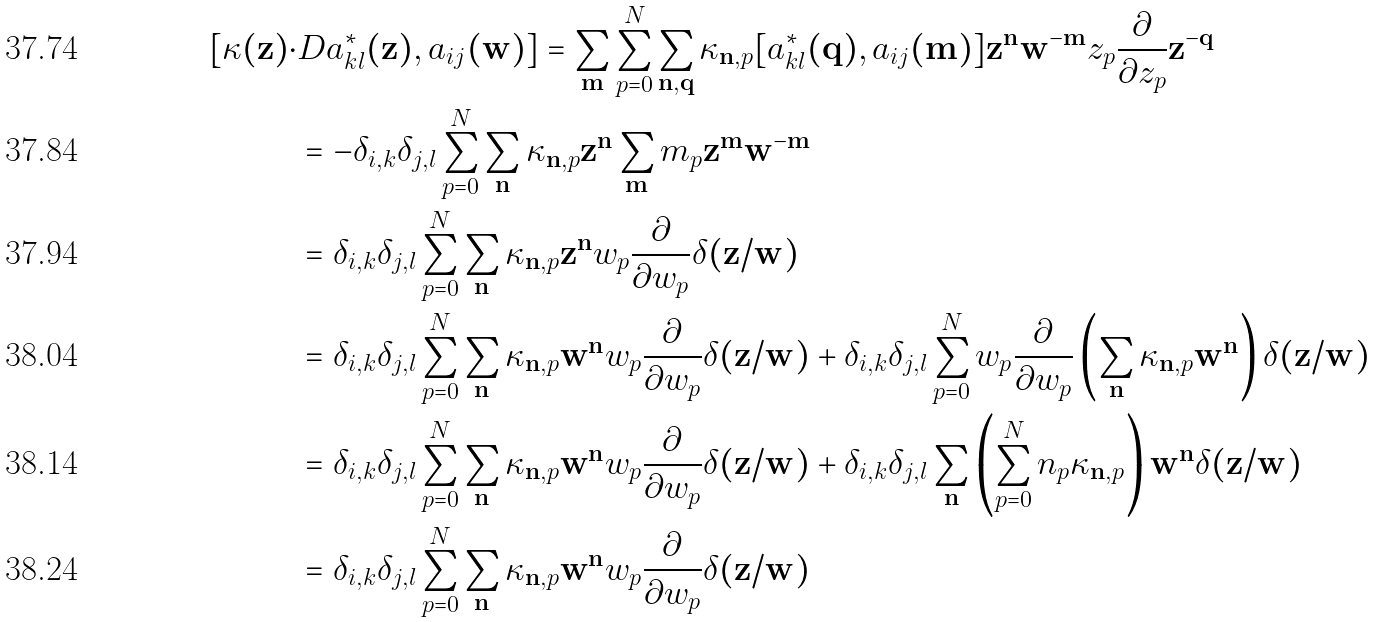Convert formula to latex. <formula><loc_0><loc_0><loc_500><loc_500>[ \kappa ( \mathbf z ) \cdot & D a _ { k l } ^ { * } ( \mathbf z ) , a _ { i j } ( \mathbf w ) ] = \sum _ { \mathbf m } \sum _ { p = 0 } ^ { N } \sum _ { \mathbf n , \mathbf q } \kappa _ { \mathbf n , p } [ a _ { k l } ^ { * } ( \mathbf q ) , a _ { i j } ( \mathbf m ) ] \mathbf z ^ { \mathbf n } \mathbf w ^ { - \mathbf m } z _ { p } { \frac { \partial } { \partial z _ { p } } } \mathbf z ^ { - \mathbf q } \\ & = - \delta _ { i , k } \delta _ { j , l } \sum _ { p = 0 } ^ { N } \sum _ { \mathbf n } \kappa _ { \mathbf n , p } \mathbf z ^ { \mathbf n } \sum _ { \mathbf m } m _ { p } \mathbf z ^ { \mathbf m } \mathbf w ^ { - \mathbf m } \\ & = \delta _ { i , k } \delta _ { j , l } \sum _ { p = 0 } ^ { N } \sum _ { \mathbf n } \kappa _ { \mathbf n , p } \mathbf z ^ { \mathbf n } w _ { p } { \frac { \partial } { \partial w _ { p } } } \delta ( \mathbf z / \mathbf w ) \\ & = \delta _ { i , k } \delta _ { j , l } \sum _ { p = 0 } ^ { N } \sum _ { \mathbf n } \kappa _ { \mathbf n , p } \mathbf w ^ { \mathbf n } w _ { p } { \frac { \partial } { \partial w _ { p } } } \delta ( \mathbf z / \mathbf w ) + \delta _ { i , k } \delta _ { j , l } \sum _ { p = 0 } ^ { N } w _ { p } { \frac { \partial } { \partial w _ { p } } } \left ( \sum _ { \mathbf n } \kappa _ { \mathbf n , p } \mathbf w ^ { \mathbf n } \right ) \delta ( \mathbf z / \mathbf w ) \\ & = \delta _ { i , k } \delta _ { j , l } \sum _ { p = 0 } ^ { N } \sum _ { \mathbf n } \kappa _ { \mathbf n , p } \mathbf w ^ { \mathbf n } w _ { p } { \frac { \partial } { \partial w _ { p } } } \delta ( \mathbf z / \mathbf w ) + \delta _ { i , k } \delta _ { j , l } \sum _ { \mathbf n } \left ( \sum _ { p = 0 } ^ { N } n _ { p } \kappa _ { \mathbf n , p } \right ) \mathbf w ^ { \mathbf n } \delta ( \mathbf z / \mathbf w ) \\ & = \delta _ { i , k } \delta _ { j , l } \sum _ { p = 0 } ^ { N } \sum _ { \mathbf n } \kappa _ { \mathbf n , p } \mathbf w ^ { \mathbf n } w _ { p } { \frac { \partial } { \partial w _ { p } } } \delta ( \mathbf z / \mathbf w )</formula> 